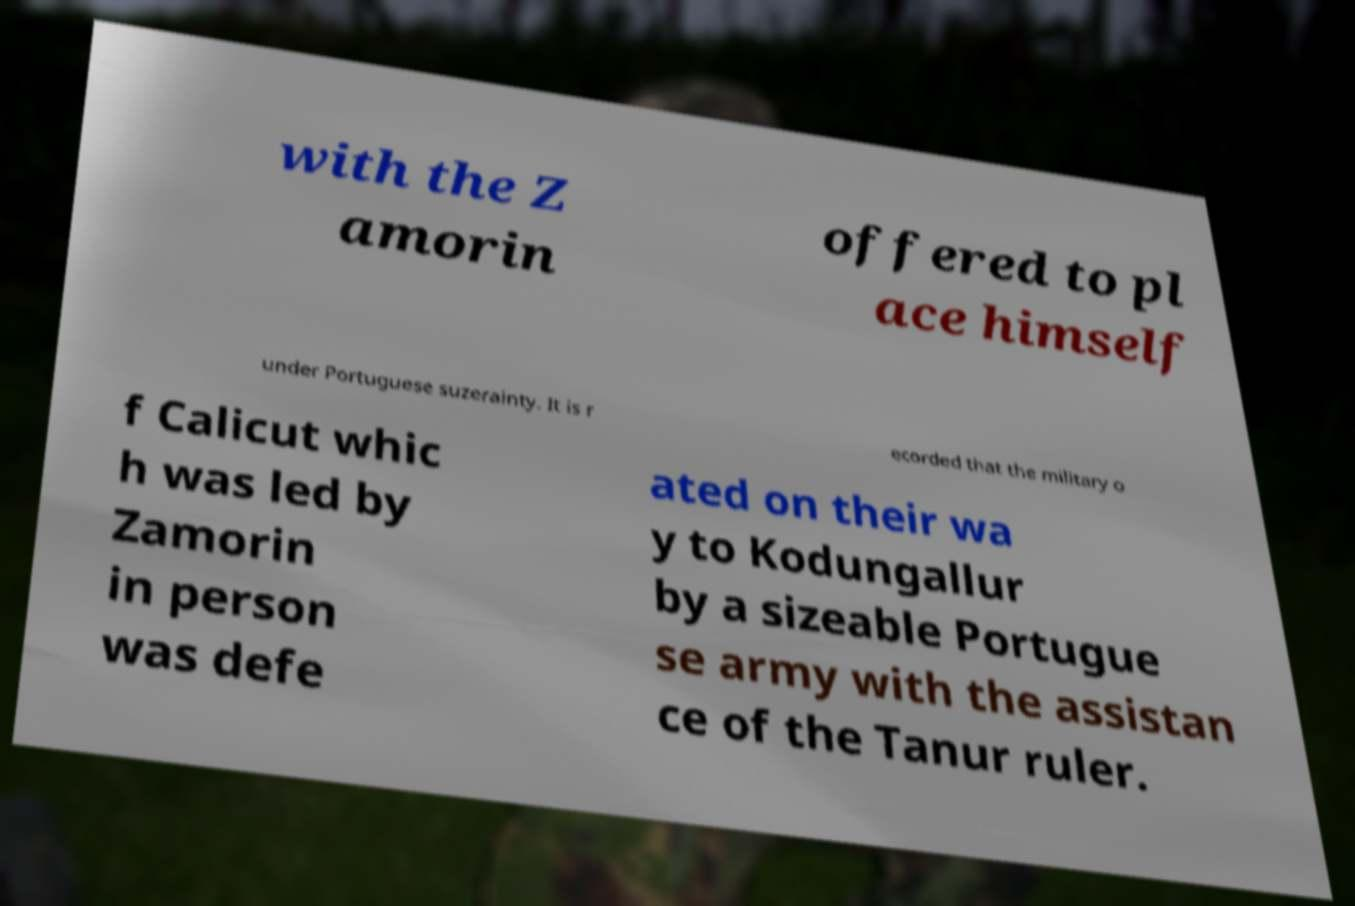Please read and relay the text visible in this image. What does it say? with the Z amorin offered to pl ace himself under Portuguese suzerainty. It is r ecorded that the military o f Calicut whic h was led by Zamorin in person was defe ated on their wa y to Kodungallur by a sizeable Portugue se army with the assistan ce of the Tanur ruler. 